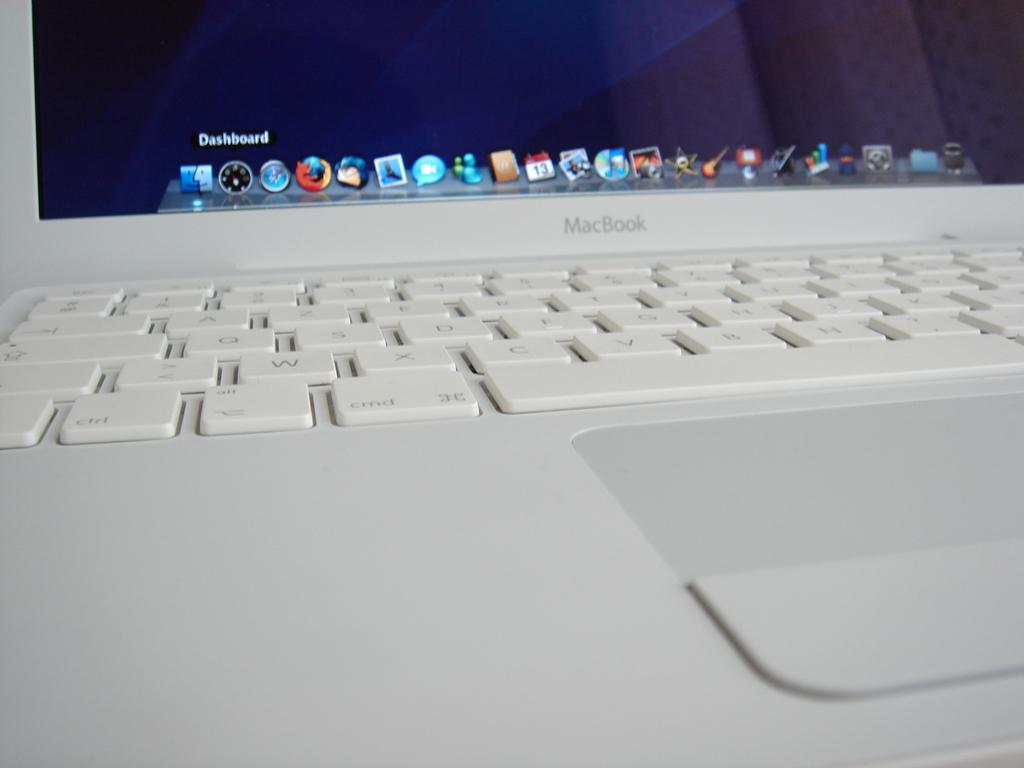What type of device is partially visible in the image? There is a keyboard in the image. What can be seen connected to the keyboard? The keyboard is connected to a laptop monitor in the image. What type of cork can be seen on the keyboard in the image? There is no cork present on the keyboard in the image. 